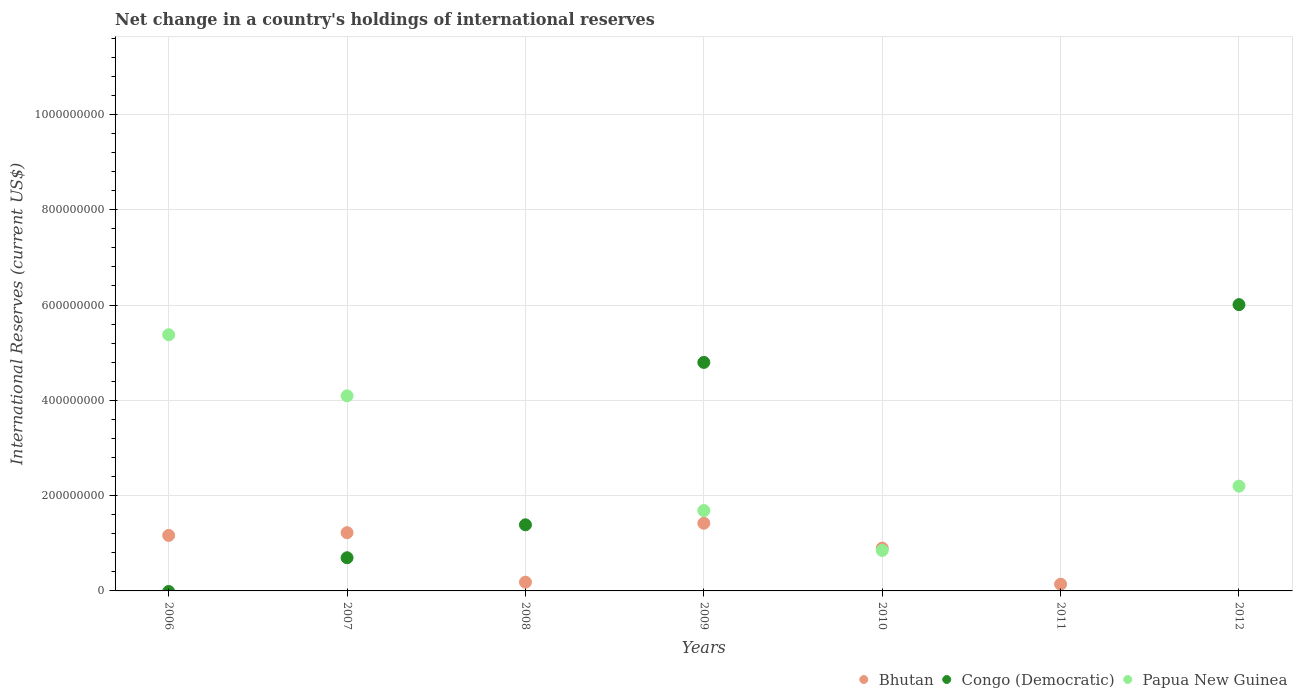How many different coloured dotlines are there?
Provide a short and direct response. 3. What is the international reserves in Congo (Democratic) in 2009?
Keep it short and to the point. 4.80e+08. Across all years, what is the maximum international reserves in Bhutan?
Offer a very short reply. 1.42e+08. In which year was the international reserves in Bhutan maximum?
Your response must be concise. 2009. What is the total international reserves in Papua New Guinea in the graph?
Your response must be concise. 1.42e+09. What is the difference between the international reserves in Congo (Democratic) in 2007 and that in 2012?
Offer a terse response. -5.31e+08. What is the difference between the international reserves in Congo (Democratic) in 2008 and the international reserves in Papua New Guinea in 2009?
Provide a short and direct response. -2.99e+07. What is the average international reserves in Congo (Democratic) per year?
Provide a succinct answer. 1.84e+08. In the year 2007, what is the difference between the international reserves in Congo (Democratic) and international reserves in Bhutan?
Offer a very short reply. -5.27e+07. In how many years, is the international reserves in Congo (Democratic) greater than 680000000 US$?
Your answer should be compact. 0. What is the ratio of the international reserves in Bhutan in 2008 to that in 2010?
Ensure brevity in your answer.  0.2. What is the difference between the highest and the second highest international reserves in Papua New Guinea?
Give a very brief answer. 1.28e+08. What is the difference between the highest and the lowest international reserves in Congo (Democratic)?
Provide a succinct answer. 6.01e+08. In how many years, is the international reserves in Papua New Guinea greater than the average international reserves in Papua New Guinea taken over all years?
Your answer should be very brief. 3. Is the sum of the international reserves in Papua New Guinea in 2010 and 2012 greater than the maximum international reserves in Bhutan across all years?
Keep it short and to the point. Yes. Is it the case that in every year, the sum of the international reserves in Papua New Guinea and international reserves in Congo (Democratic)  is greater than the international reserves in Bhutan?
Your answer should be very brief. No. Does the international reserves in Papua New Guinea monotonically increase over the years?
Keep it short and to the point. No. Is the international reserves in Bhutan strictly greater than the international reserves in Papua New Guinea over the years?
Provide a short and direct response. No. How many dotlines are there?
Give a very brief answer. 3. Does the graph contain grids?
Your answer should be compact. Yes. Where does the legend appear in the graph?
Your answer should be compact. Bottom right. How many legend labels are there?
Ensure brevity in your answer.  3. How are the legend labels stacked?
Keep it short and to the point. Horizontal. What is the title of the graph?
Offer a terse response. Net change in a country's holdings of international reserves. Does "Uzbekistan" appear as one of the legend labels in the graph?
Provide a succinct answer. No. What is the label or title of the Y-axis?
Make the answer very short. International Reserves (current US$). What is the International Reserves (current US$) of Bhutan in 2006?
Keep it short and to the point. 1.16e+08. What is the International Reserves (current US$) in Papua New Guinea in 2006?
Your answer should be very brief. 5.38e+08. What is the International Reserves (current US$) of Bhutan in 2007?
Your response must be concise. 1.22e+08. What is the International Reserves (current US$) of Congo (Democratic) in 2007?
Ensure brevity in your answer.  6.96e+07. What is the International Reserves (current US$) of Papua New Guinea in 2007?
Provide a short and direct response. 4.09e+08. What is the International Reserves (current US$) of Bhutan in 2008?
Your answer should be very brief. 1.84e+07. What is the International Reserves (current US$) in Congo (Democratic) in 2008?
Your answer should be compact. 1.39e+08. What is the International Reserves (current US$) in Papua New Guinea in 2008?
Give a very brief answer. 0. What is the International Reserves (current US$) in Bhutan in 2009?
Offer a terse response. 1.42e+08. What is the International Reserves (current US$) of Congo (Democratic) in 2009?
Keep it short and to the point. 4.80e+08. What is the International Reserves (current US$) in Papua New Guinea in 2009?
Your answer should be very brief. 1.69e+08. What is the International Reserves (current US$) in Bhutan in 2010?
Provide a succinct answer. 8.99e+07. What is the International Reserves (current US$) in Papua New Guinea in 2010?
Provide a succinct answer. 8.50e+07. What is the International Reserves (current US$) in Bhutan in 2011?
Provide a succinct answer. 1.41e+07. What is the International Reserves (current US$) in Congo (Democratic) in 2011?
Offer a very short reply. 0. What is the International Reserves (current US$) of Bhutan in 2012?
Keep it short and to the point. 0. What is the International Reserves (current US$) of Congo (Democratic) in 2012?
Ensure brevity in your answer.  6.01e+08. What is the International Reserves (current US$) in Papua New Guinea in 2012?
Provide a succinct answer. 2.20e+08. Across all years, what is the maximum International Reserves (current US$) in Bhutan?
Ensure brevity in your answer.  1.42e+08. Across all years, what is the maximum International Reserves (current US$) in Congo (Democratic)?
Provide a succinct answer. 6.01e+08. Across all years, what is the maximum International Reserves (current US$) in Papua New Guinea?
Ensure brevity in your answer.  5.38e+08. Across all years, what is the minimum International Reserves (current US$) of Congo (Democratic)?
Keep it short and to the point. 0. What is the total International Reserves (current US$) of Bhutan in the graph?
Offer a terse response. 5.03e+08. What is the total International Reserves (current US$) of Congo (Democratic) in the graph?
Give a very brief answer. 1.29e+09. What is the total International Reserves (current US$) of Papua New Guinea in the graph?
Provide a short and direct response. 1.42e+09. What is the difference between the International Reserves (current US$) in Bhutan in 2006 and that in 2007?
Offer a very short reply. -5.80e+06. What is the difference between the International Reserves (current US$) of Papua New Guinea in 2006 and that in 2007?
Give a very brief answer. 1.28e+08. What is the difference between the International Reserves (current US$) of Bhutan in 2006 and that in 2008?
Offer a very short reply. 9.81e+07. What is the difference between the International Reserves (current US$) in Bhutan in 2006 and that in 2009?
Provide a short and direct response. -2.55e+07. What is the difference between the International Reserves (current US$) of Papua New Guinea in 2006 and that in 2009?
Your response must be concise. 3.69e+08. What is the difference between the International Reserves (current US$) in Bhutan in 2006 and that in 2010?
Your answer should be compact. 2.66e+07. What is the difference between the International Reserves (current US$) in Papua New Guinea in 2006 and that in 2010?
Make the answer very short. 4.53e+08. What is the difference between the International Reserves (current US$) of Bhutan in 2006 and that in 2011?
Ensure brevity in your answer.  1.02e+08. What is the difference between the International Reserves (current US$) of Papua New Guinea in 2006 and that in 2012?
Your response must be concise. 3.18e+08. What is the difference between the International Reserves (current US$) in Bhutan in 2007 and that in 2008?
Provide a succinct answer. 1.04e+08. What is the difference between the International Reserves (current US$) in Congo (Democratic) in 2007 and that in 2008?
Your response must be concise. -6.91e+07. What is the difference between the International Reserves (current US$) in Bhutan in 2007 and that in 2009?
Your response must be concise. -1.97e+07. What is the difference between the International Reserves (current US$) of Congo (Democratic) in 2007 and that in 2009?
Your answer should be compact. -4.10e+08. What is the difference between the International Reserves (current US$) of Papua New Guinea in 2007 and that in 2009?
Your answer should be compact. 2.41e+08. What is the difference between the International Reserves (current US$) of Bhutan in 2007 and that in 2010?
Offer a terse response. 3.24e+07. What is the difference between the International Reserves (current US$) in Papua New Guinea in 2007 and that in 2010?
Provide a succinct answer. 3.24e+08. What is the difference between the International Reserves (current US$) of Bhutan in 2007 and that in 2011?
Offer a very short reply. 1.08e+08. What is the difference between the International Reserves (current US$) in Congo (Democratic) in 2007 and that in 2012?
Offer a terse response. -5.31e+08. What is the difference between the International Reserves (current US$) in Papua New Guinea in 2007 and that in 2012?
Your answer should be very brief. 1.90e+08. What is the difference between the International Reserves (current US$) of Bhutan in 2008 and that in 2009?
Your answer should be compact. -1.24e+08. What is the difference between the International Reserves (current US$) in Congo (Democratic) in 2008 and that in 2009?
Your answer should be very brief. -3.41e+08. What is the difference between the International Reserves (current US$) in Bhutan in 2008 and that in 2010?
Offer a very short reply. -7.15e+07. What is the difference between the International Reserves (current US$) in Bhutan in 2008 and that in 2011?
Your answer should be very brief. 4.26e+06. What is the difference between the International Reserves (current US$) in Congo (Democratic) in 2008 and that in 2012?
Your response must be concise. -4.62e+08. What is the difference between the International Reserves (current US$) of Bhutan in 2009 and that in 2010?
Your answer should be very brief. 5.21e+07. What is the difference between the International Reserves (current US$) of Papua New Guinea in 2009 and that in 2010?
Keep it short and to the point. 8.36e+07. What is the difference between the International Reserves (current US$) of Bhutan in 2009 and that in 2011?
Ensure brevity in your answer.  1.28e+08. What is the difference between the International Reserves (current US$) in Congo (Democratic) in 2009 and that in 2012?
Provide a short and direct response. -1.21e+08. What is the difference between the International Reserves (current US$) in Papua New Guinea in 2009 and that in 2012?
Offer a terse response. -5.13e+07. What is the difference between the International Reserves (current US$) of Bhutan in 2010 and that in 2011?
Your answer should be very brief. 7.58e+07. What is the difference between the International Reserves (current US$) of Papua New Guinea in 2010 and that in 2012?
Give a very brief answer. -1.35e+08. What is the difference between the International Reserves (current US$) of Bhutan in 2006 and the International Reserves (current US$) of Congo (Democratic) in 2007?
Provide a short and direct response. 4.69e+07. What is the difference between the International Reserves (current US$) of Bhutan in 2006 and the International Reserves (current US$) of Papua New Guinea in 2007?
Provide a short and direct response. -2.93e+08. What is the difference between the International Reserves (current US$) of Bhutan in 2006 and the International Reserves (current US$) of Congo (Democratic) in 2008?
Ensure brevity in your answer.  -2.23e+07. What is the difference between the International Reserves (current US$) in Bhutan in 2006 and the International Reserves (current US$) in Congo (Democratic) in 2009?
Your response must be concise. -3.63e+08. What is the difference between the International Reserves (current US$) in Bhutan in 2006 and the International Reserves (current US$) in Papua New Guinea in 2009?
Your answer should be very brief. -5.21e+07. What is the difference between the International Reserves (current US$) of Bhutan in 2006 and the International Reserves (current US$) of Papua New Guinea in 2010?
Give a very brief answer. 3.15e+07. What is the difference between the International Reserves (current US$) of Bhutan in 2006 and the International Reserves (current US$) of Congo (Democratic) in 2012?
Provide a short and direct response. -4.84e+08. What is the difference between the International Reserves (current US$) of Bhutan in 2006 and the International Reserves (current US$) of Papua New Guinea in 2012?
Offer a very short reply. -1.03e+08. What is the difference between the International Reserves (current US$) in Bhutan in 2007 and the International Reserves (current US$) in Congo (Democratic) in 2008?
Your answer should be compact. -1.65e+07. What is the difference between the International Reserves (current US$) of Bhutan in 2007 and the International Reserves (current US$) of Congo (Democratic) in 2009?
Make the answer very short. -3.57e+08. What is the difference between the International Reserves (current US$) of Bhutan in 2007 and the International Reserves (current US$) of Papua New Guinea in 2009?
Provide a short and direct response. -4.63e+07. What is the difference between the International Reserves (current US$) in Congo (Democratic) in 2007 and the International Reserves (current US$) in Papua New Guinea in 2009?
Keep it short and to the point. -9.90e+07. What is the difference between the International Reserves (current US$) of Bhutan in 2007 and the International Reserves (current US$) of Papua New Guinea in 2010?
Give a very brief answer. 3.73e+07. What is the difference between the International Reserves (current US$) in Congo (Democratic) in 2007 and the International Reserves (current US$) in Papua New Guinea in 2010?
Offer a terse response. -1.54e+07. What is the difference between the International Reserves (current US$) in Bhutan in 2007 and the International Reserves (current US$) in Congo (Democratic) in 2012?
Ensure brevity in your answer.  -4.79e+08. What is the difference between the International Reserves (current US$) in Bhutan in 2007 and the International Reserves (current US$) in Papua New Guinea in 2012?
Make the answer very short. -9.76e+07. What is the difference between the International Reserves (current US$) of Congo (Democratic) in 2007 and the International Reserves (current US$) of Papua New Guinea in 2012?
Make the answer very short. -1.50e+08. What is the difference between the International Reserves (current US$) of Bhutan in 2008 and the International Reserves (current US$) of Congo (Democratic) in 2009?
Make the answer very short. -4.61e+08. What is the difference between the International Reserves (current US$) in Bhutan in 2008 and the International Reserves (current US$) in Papua New Guinea in 2009?
Offer a very short reply. -1.50e+08. What is the difference between the International Reserves (current US$) in Congo (Democratic) in 2008 and the International Reserves (current US$) in Papua New Guinea in 2009?
Keep it short and to the point. -2.99e+07. What is the difference between the International Reserves (current US$) in Bhutan in 2008 and the International Reserves (current US$) in Papua New Guinea in 2010?
Provide a short and direct response. -6.66e+07. What is the difference between the International Reserves (current US$) of Congo (Democratic) in 2008 and the International Reserves (current US$) of Papua New Guinea in 2010?
Give a very brief answer. 5.38e+07. What is the difference between the International Reserves (current US$) of Bhutan in 2008 and the International Reserves (current US$) of Congo (Democratic) in 2012?
Provide a short and direct response. -5.82e+08. What is the difference between the International Reserves (current US$) of Bhutan in 2008 and the International Reserves (current US$) of Papua New Guinea in 2012?
Give a very brief answer. -2.01e+08. What is the difference between the International Reserves (current US$) of Congo (Democratic) in 2008 and the International Reserves (current US$) of Papua New Guinea in 2012?
Ensure brevity in your answer.  -8.11e+07. What is the difference between the International Reserves (current US$) of Bhutan in 2009 and the International Reserves (current US$) of Papua New Guinea in 2010?
Your response must be concise. 5.70e+07. What is the difference between the International Reserves (current US$) in Congo (Democratic) in 2009 and the International Reserves (current US$) in Papua New Guinea in 2010?
Offer a very short reply. 3.95e+08. What is the difference between the International Reserves (current US$) in Bhutan in 2009 and the International Reserves (current US$) in Congo (Democratic) in 2012?
Keep it short and to the point. -4.59e+08. What is the difference between the International Reserves (current US$) in Bhutan in 2009 and the International Reserves (current US$) in Papua New Guinea in 2012?
Keep it short and to the point. -7.79e+07. What is the difference between the International Reserves (current US$) in Congo (Democratic) in 2009 and the International Reserves (current US$) in Papua New Guinea in 2012?
Make the answer very short. 2.60e+08. What is the difference between the International Reserves (current US$) of Bhutan in 2010 and the International Reserves (current US$) of Congo (Democratic) in 2012?
Your answer should be very brief. -5.11e+08. What is the difference between the International Reserves (current US$) of Bhutan in 2010 and the International Reserves (current US$) of Papua New Guinea in 2012?
Ensure brevity in your answer.  -1.30e+08. What is the difference between the International Reserves (current US$) of Bhutan in 2011 and the International Reserves (current US$) of Congo (Democratic) in 2012?
Make the answer very short. -5.87e+08. What is the difference between the International Reserves (current US$) in Bhutan in 2011 and the International Reserves (current US$) in Papua New Guinea in 2012?
Offer a terse response. -2.06e+08. What is the average International Reserves (current US$) of Bhutan per year?
Your response must be concise. 7.19e+07. What is the average International Reserves (current US$) of Congo (Democratic) per year?
Offer a terse response. 1.84e+08. What is the average International Reserves (current US$) in Papua New Guinea per year?
Offer a terse response. 2.03e+08. In the year 2006, what is the difference between the International Reserves (current US$) in Bhutan and International Reserves (current US$) in Papua New Guinea?
Your response must be concise. -4.21e+08. In the year 2007, what is the difference between the International Reserves (current US$) of Bhutan and International Reserves (current US$) of Congo (Democratic)?
Your response must be concise. 5.27e+07. In the year 2007, what is the difference between the International Reserves (current US$) of Bhutan and International Reserves (current US$) of Papua New Guinea?
Keep it short and to the point. -2.87e+08. In the year 2007, what is the difference between the International Reserves (current US$) in Congo (Democratic) and International Reserves (current US$) in Papua New Guinea?
Your response must be concise. -3.40e+08. In the year 2008, what is the difference between the International Reserves (current US$) in Bhutan and International Reserves (current US$) in Congo (Democratic)?
Offer a very short reply. -1.20e+08. In the year 2009, what is the difference between the International Reserves (current US$) of Bhutan and International Reserves (current US$) of Congo (Democratic)?
Provide a succinct answer. -3.38e+08. In the year 2009, what is the difference between the International Reserves (current US$) in Bhutan and International Reserves (current US$) in Papua New Guinea?
Ensure brevity in your answer.  -2.66e+07. In the year 2009, what is the difference between the International Reserves (current US$) in Congo (Democratic) and International Reserves (current US$) in Papua New Guinea?
Offer a very short reply. 3.11e+08. In the year 2010, what is the difference between the International Reserves (current US$) of Bhutan and International Reserves (current US$) of Papua New Guinea?
Your response must be concise. 4.90e+06. In the year 2012, what is the difference between the International Reserves (current US$) in Congo (Democratic) and International Reserves (current US$) in Papua New Guinea?
Provide a succinct answer. 3.81e+08. What is the ratio of the International Reserves (current US$) in Bhutan in 2006 to that in 2007?
Ensure brevity in your answer.  0.95. What is the ratio of the International Reserves (current US$) of Papua New Guinea in 2006 to that in 2007?
Provide a short and direct response. 1.31. What is the ratio of the International Reserves (current US$) in Bhutan in 2006 to that in 2008?
Provide a short and direct response. 6.34. What is the ratio of the International Reserves (current US$) of Bhutan in 2006 to that in 2009?
Offer a very short reply. 0.82. What is the ratio of the International Reserves (current US$) in Papua New Guinea in 2006 to that in 2009?
Your response must be concise. 3.19. What is the ratio of the International Reserves (current US$) in Bhutan in 2006 to that in 2010?
Your response must be concise. 1.3. What is the ratio of the International Reserves (current US$) in Papua New Guinea in 2006 to that in 2010?
Give a very brief answer. 6.33. What is the ratio of the International Reserves (current US$) of Bhutan in 2006 to that in 2011?
Provide a short and direct response. 8.25. What is the ratio of the International Reserves (current US$) of Papua New Guinea in 2006 to that in 2012?
Give a very brief answer. 2.45. What is the ratio of the International Reserves (current US$) of Bhutan in 2007 to that in 2008?
Offer a very short reply. 6.65. What is the ratio of the International Reserves (current US$) in Congo (Democratic) in 2007 to that in 2008?
Provide a succinct answer. 0.5. What is the ratio of the International Reserves (current US$) in Bhutan in 2007 to that in 2009?
Keep it short and to the point. 0.86. What is the ratio of the International Reserves (current US$) of Congo (Democratic) in 2007 to that in 2009?
Your answer should be compact. 0.15. What is the ratio of the International Reserves (current US$) of Papua New Guinea in 2007 to that in 2009?
Your answer should be very brief. 2.43. What is the ratio of the International Reserves (current US$) in Bhutan in 2007 to that in 2010?
Offer a terse response. 1.36. What is the ratio of the International Reserves (current US$) of Papua New Guinea in 2007 to that in 2010?
Make the answer very short. 4.82. What is the ratio of the International Reserves (current US$) of Bhutan in 2007 to that in 2011?
Your answer should be compact. 8.66. What is the ratio of the International Reserves (current US$) of Congo (Democratic) in 2007 to that in 2012?
Make the answer very short. 0.12. What is the ratio of the International Reserves (current US$) in Papua New Guinea in 2007 to that in 2012?
Provide a succinct answer. 1.86. What is the ratio of the International Reserves (current US$) of Bhutan in 2008 to that in 2009?
Your answer should be compact. 0.13. What is the ratio of the International Reserves (current US$) in Congo (Democratic) in 2008 to that in 2009?
Provide a succinct answer. 0.29. What is the ratio of the International Reserves (current US$) of Bhutan in 2008 to that in 2010?
Offer a very short reply. 0.2. What is the ratio of the International Reserves (current US$) of Bhutan in 2008 to that in 2011?
Provide a succinct answer. 1.3. What is the ratio of the International Reserves (current US$) in Congo (Democratic) in 2008 to that in 2012?
Make the answer very short. 0.23. What is the ratio of the International Reserves (current US$) of Bhutan in 2009 to that in 2010?
Provide a short and direct response. 1.58. What is the ratio of the International Reserves (current US$) of Papua New Guinea in 2009 to that in 2010?
Make the answer very short. 1.98. What is the ratio of the International Reserves (current US$) in Bhutan in 2009 to that in 2011?
Keep it short and to the point. 10.06. What is the ratio of the International Reserves (current US$) in Congo (Democratic) in 2009 to that in 2012?
Keep it short and to the point. 0.8. What is the ratio of the International Reserves (current US$) in Papua New Guinea in 2009 to that in 2012?
Offer a very short reply. 0.77. What is the ratio of the International Reserves (current US$) of Bhutan in 2010 to that in 2011?
Give a very brief answer. 6.37. What is the ratio of the International Reserves (current US$) in Papua New Guinea in 2010 to that in 2012?
Offer a very short reply. 0.39. What is the difference between the highest and the second highest International Reserves (current US$) in Bhutan?
Make the answer very short. 1.97e+07. What is the difference between the highest and the second highest International Reserves (current US$) in Congo (Democratic)?
Offer a very short reply. 1.21e+08. What is the difference between the highest and the second highest International Reserves (current US$) of Papua New Guinea?
Offer a very short reply. 1.28e+08. What is the difference between the highest and the lowest International Reserves (current US$) of Bhutan?
Provide a succinct answer. 1.42e+08. What is the difference between the highest and the lowest International Reserves (current US$) in Congo (Democratic)?
Offer a terse response. 6.01e+08. What is the difference between the highest and the lowest International Reserves (current US$) in Papua New Guinea?
Offer a terse response. 5.38e+08. 